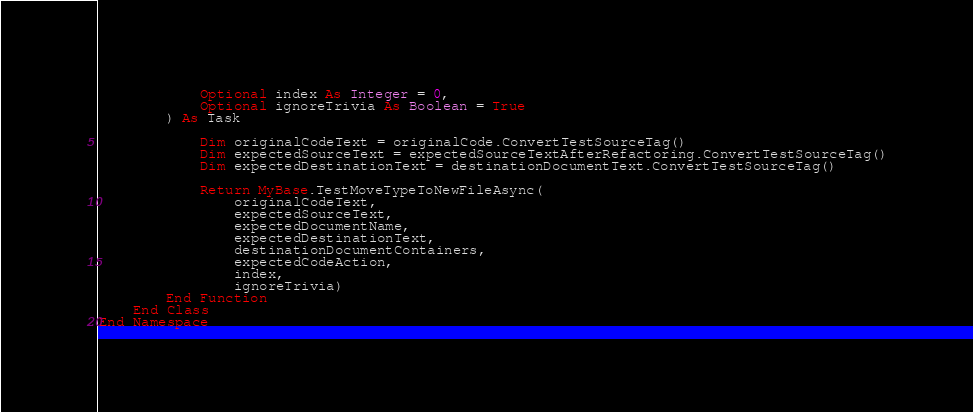<code> <loc_0><loc_0><loc_500><loc_500><_VisualBasic_>            Optional index As Integer = 0,
            Optional ignoreTrivia As Boolean = True
        ) As Task

            Dim originalCodeText = originalCode.ConvertTestSourceTag()
            Dim expectedSourceText = expectedSourceTextAfterRefactoring.ConvertTestSourceTag()
            Dim expectedDestinationText = destinationDocumentText.ConvertTestSourceTag()

            Return MyBase.TestMoveTypeToNewFileAsync(
                originalCodeText,
                expectedSourceText,
                expectedDocumentName,
                expectedDestinationText,
                destinationDocumentContainers,
                expectedCodeAction,
                index,
                ignoreTrivia)
        End Function
    End Class
End Namespace
</code> 